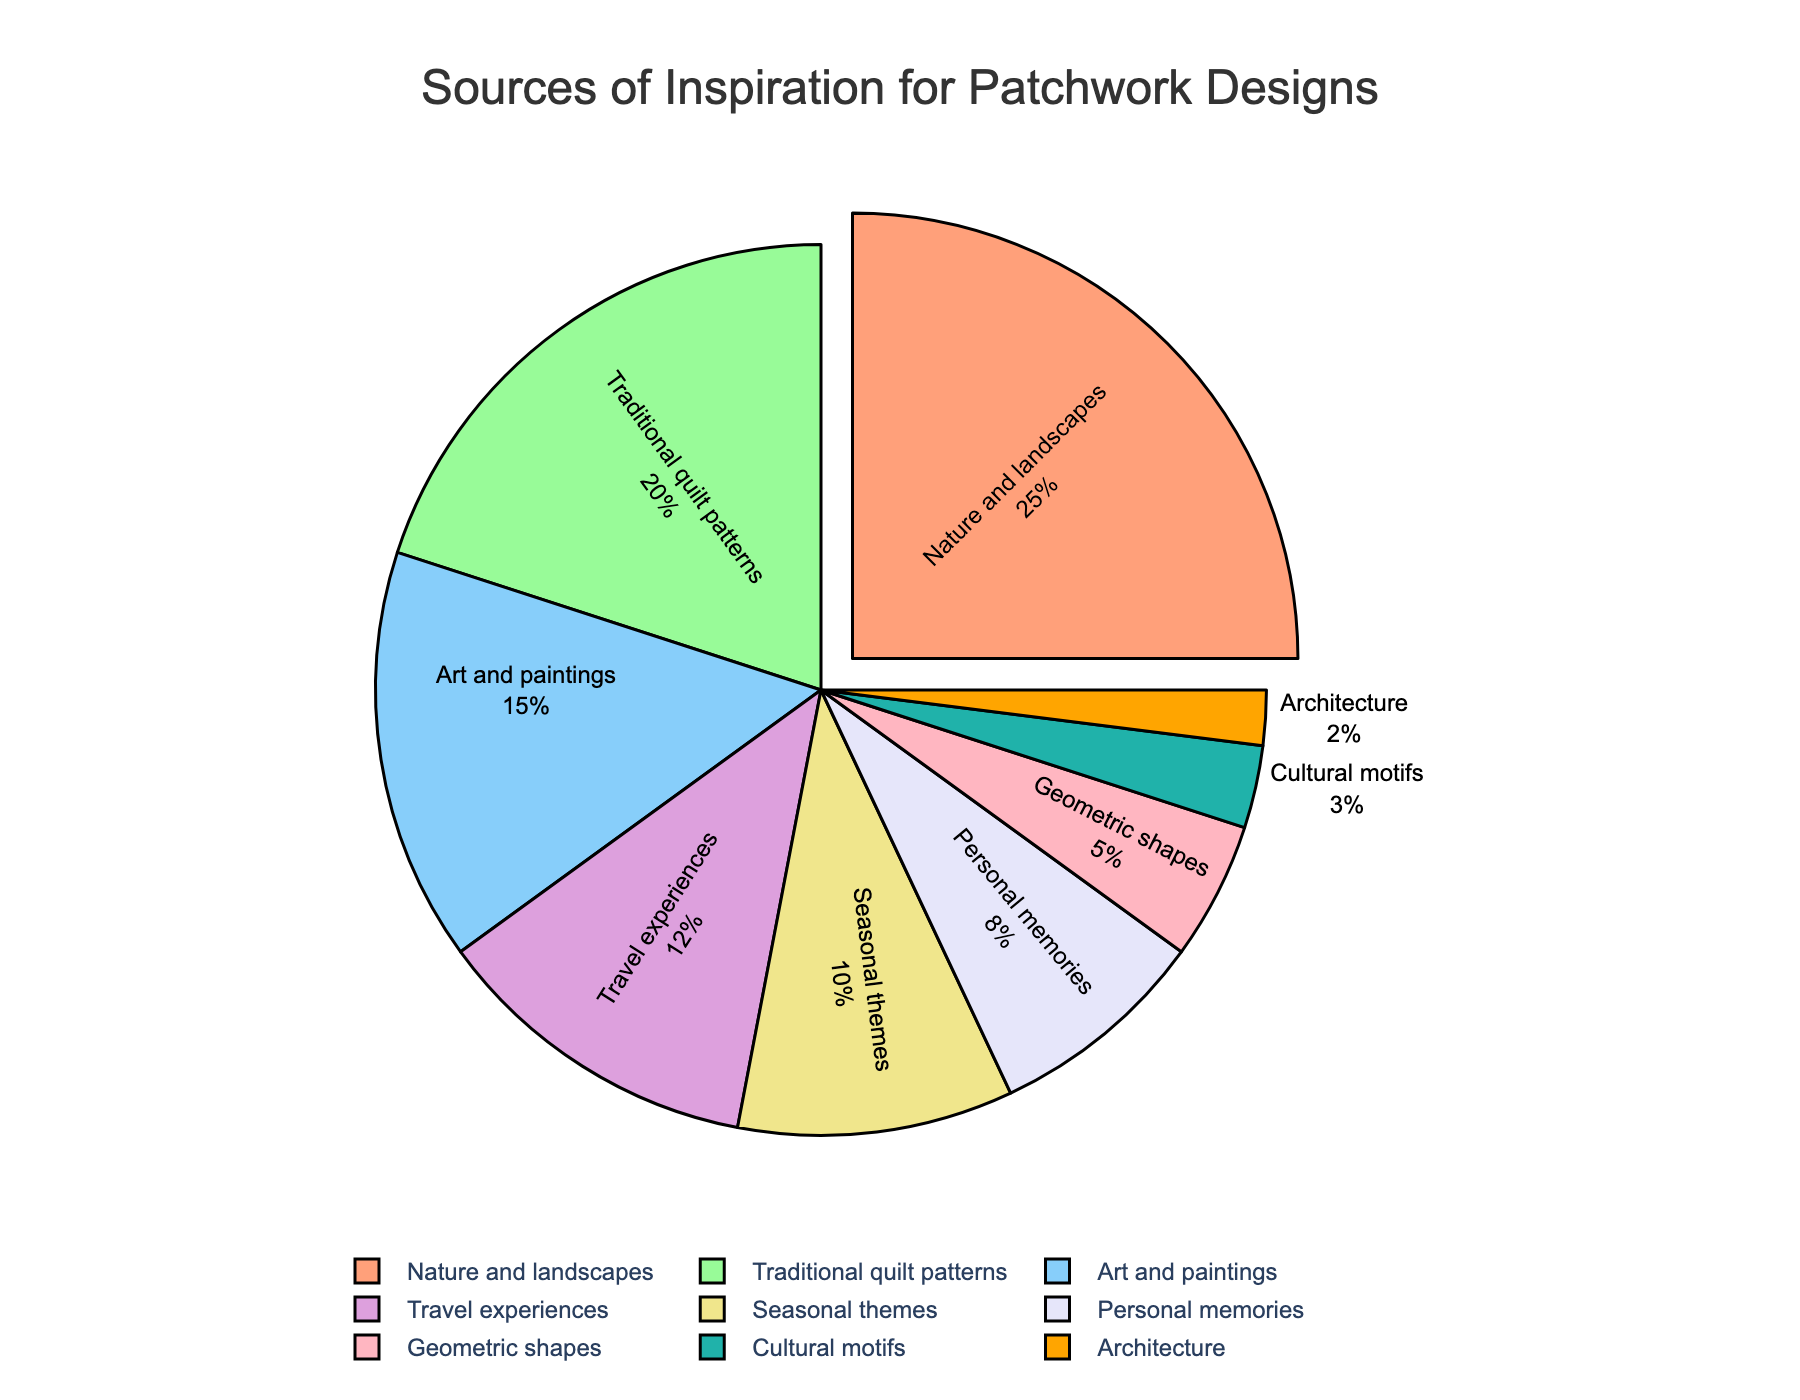What are the three least common sources of inspiration for patchwork designs? The least common sources are those with the smallest percentages. By inspecting the pie chart, Cultural motifs (3%), Architecture (2%), and Geometric shapes (5%) are the smallest slices.
Answer: Cultural motifs, Architecture, Geometric shapes Which source of inspiration has the largest share, and by how much does it exceed the second largest share? The largest source is Nature and landscapes (25%). The second largest is Traditional quilt patterns (20%). The difference is calculated as 25% - 20%.
Answer: Nature and landscapes, 5% What percentage of sources of inspiration comes from personal memories and travel experiences combined? The percentage for Personal memories is 8% and for Travel experiences is 12%. Summing them up gives 8% + 12%.
Answer: 20% Is the share of Seasonal themes greater than that of Geometric shapes? The percentage for Seasonal themes is 10%, while for Geometric shapes it is 5%. Comparing the two values, 10% is greater than 5%.
Answer: Yes How many sources of inspiration contribute less than 10% each? By inspecting the pie chart, the categories contributing less than 10% are Personal memories (8%), Geometric shapes (5%), Cultural motifs (3%), and Architecture (2%). Count these categories.
Answer: 4 What is the total percentage of sources of inspiration excluding Art and paintings and Travel experiences? To find this, we need to exclude the percentages for Art and paintings (15%) and Travel experiences (12%) from the total 100%. So, 100% - (15% + 12%).
Answer: 73% Which color represents Traditional quilt patterns and how is it visually distinguished in the pie chart? The Traditional quilt patterns slice is shown in light green and it can be distinguished from other slices by its unique color and also by checking the labels.
Answer: Light green What is the combined percentage share of Art and paintings, Nature and landscapes, and Traditional quilt patterns? Summing the percentages for Art and paintings (15%), Nature and landscapes (25%), and Traditional quilt patterns (20%) gives 15% + 25% + 20%.
Answer: 60% How much larger is the percentage of sources derived from Nature and landscapes compared to Architecture? The percentage for Nature and landscapes is 25%, while for Architecture it is 2%. The difference is calculated as 25% - 2%.
Answer: 23% What percentage of sources are represented by the segments pulled out from the pie chart? In the pie chart, the only segment that is pulled out represents Nature and landscapes with a percentage of 25%.
Answer: 25% 